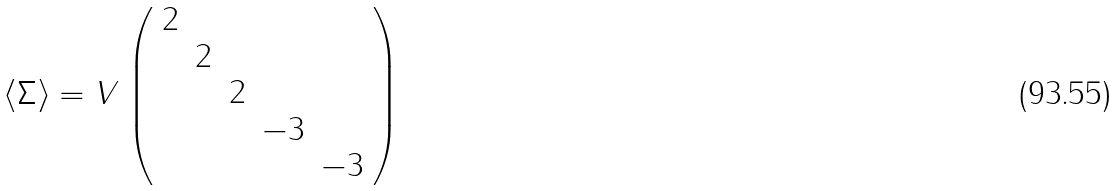Convert formula to latex. <formula><loc_0><loc_0><loc_500><loc_500>\langle \Sigma \rangle = V \left ( \begin{array} { c c c c c } 2 & & & & \\ & 2 & & & \\ & & 2 & & \\ & & & - 3 & \\ & & & & - 3 \end{array} \right )</formula> 